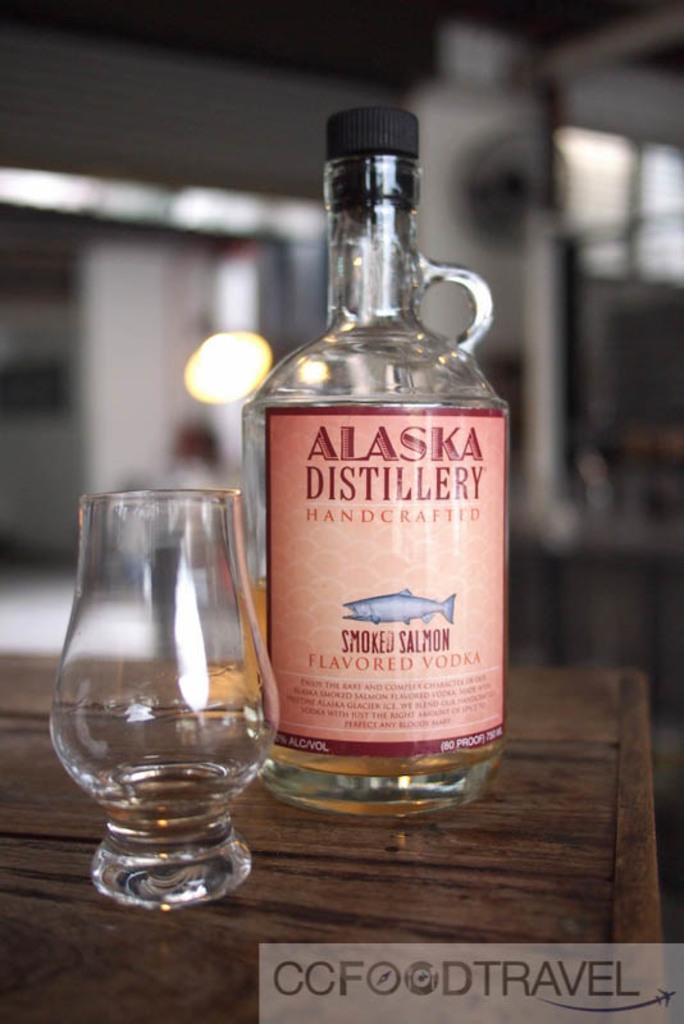What is present on the table in the image? There is a bottle and a glass on the table in the image. What can be identified from the label on the bottle? The label on the bottle says "Alaska Distillery Handcrafted Smoked Salmon Flavored Vodka." What color is the lid of the bottle? The lid of the bottle is black. What subject is the queen teaching in the room depicted in the image? There is no room or queen present in the image; it only features a bottle and a glass on a table. 